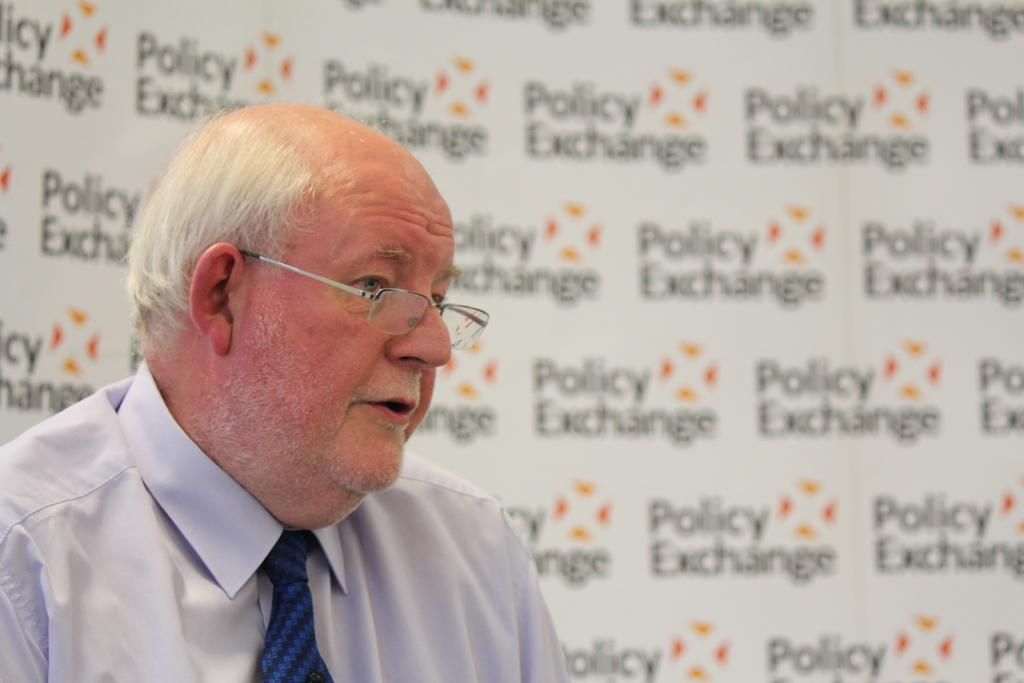Who is present in the image? There is a man in the image. What is the man wearing on his face? The man is wearing spectacles. What type of wren can be seen perched on the man's shoulder in the image? There is no wren present in the image; it only features a man wearing spectacles. 